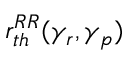Convert formula to latex. <formula><loc_0><loc_0><loc_500><loc_500>r _ { t h } ^ { R R } ( \gamma _ { r } , \gamma _ { p } )</formula> 